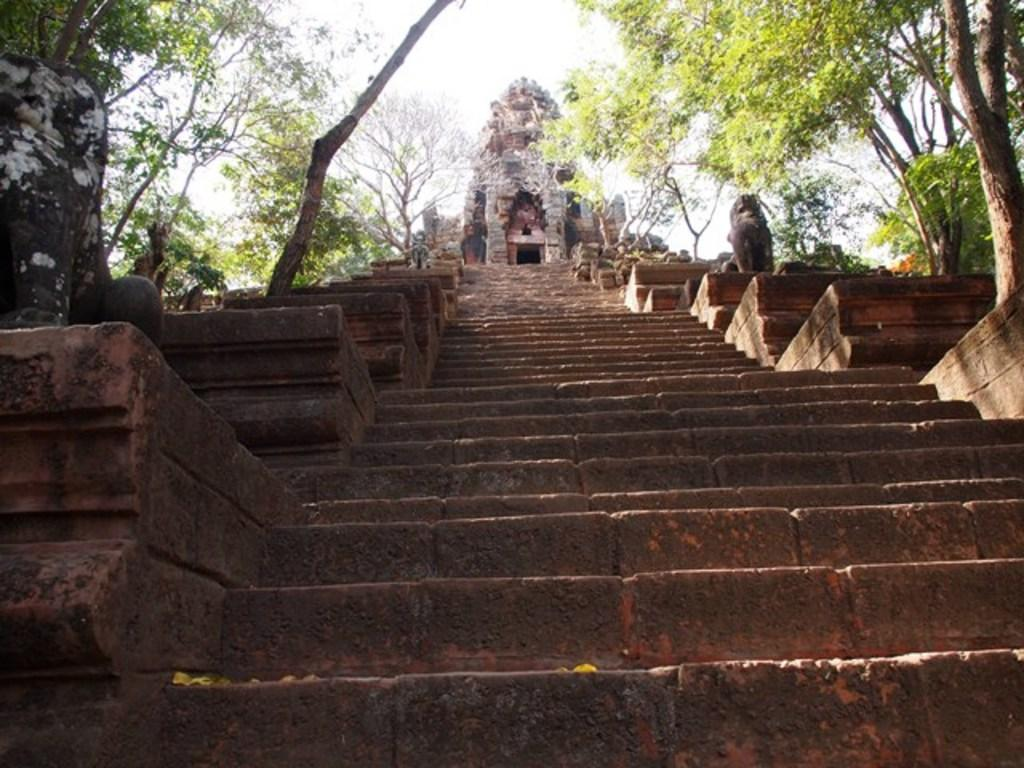What is located in the foreground of the picture? There is a sculpture and a staircase in the foreground of the picture. What can be seen at the top of the image? There are trees and a temple at the top of the image. What is the weather like in the image? The sky is sunny in the image. What type of apparel is the judge wearing in the image? There is no judge present in the image, so it is not possible to determine what type of apparel they might be wearing. 